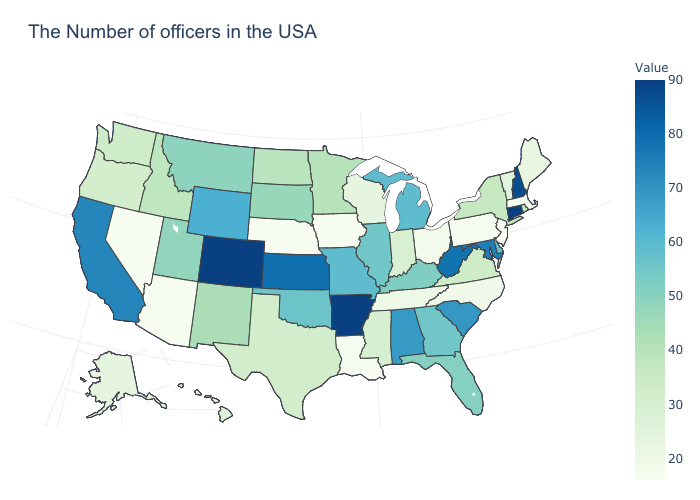Among the states that border North Dakota , which have the highest value?
Quick response, please. Montana. Does Kansas have the highest value in the USA?
Give a very brief answer. No. Does Ohio have the highest value in the MidWest?
Short answer required. No. Among the states that border North Dakota , which have the highest value?
Short answer required. Montana. 